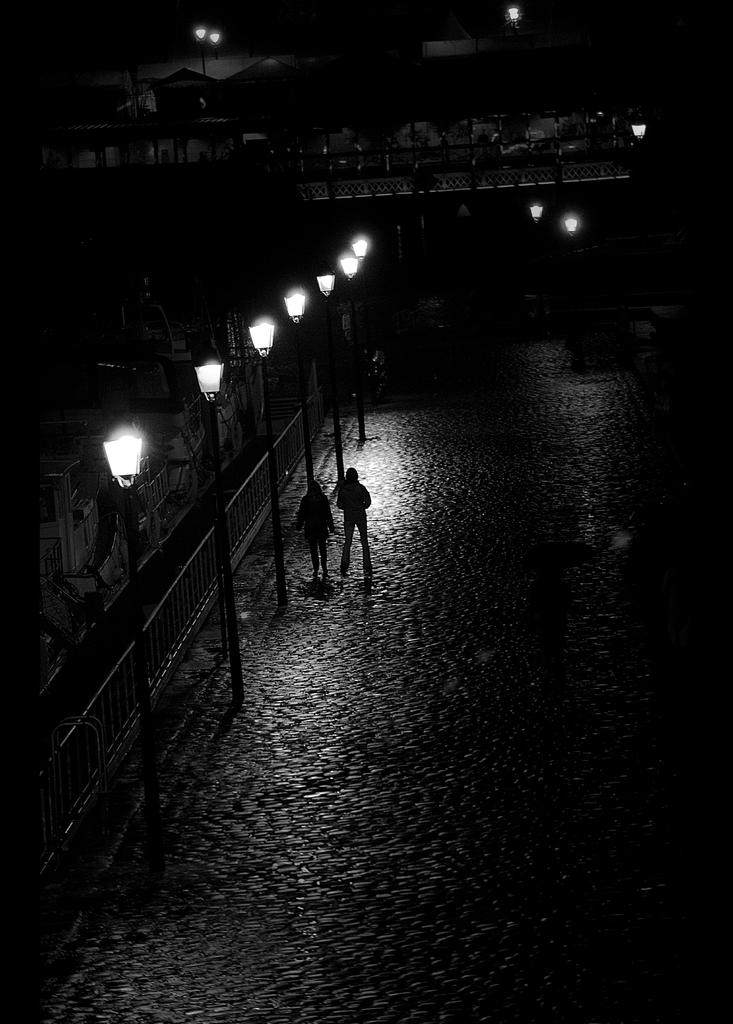How many people are standing on the road in the image? There are two persons standing on the road in the image. What structures can be seen in the image besides the road? Light poles, buildings, and a bridge are visible in the image. What type of vegetation is present in the image? Trees are present in the image. What part of the natural environment is visible in the image? The sky is visible in the image. Can you tell if the image was taken during the day or night? The image may have been taken during the night, as there is no indication of sunlight. What type of insect can be seen crawling on the toe of one of the persons in the image? There is no insect visible on any person's toe in the image. Can you describe the driving conditions in the image? There is no vehicle or driving activity visible in the image, so it is not possible to describe the driving conditions. 